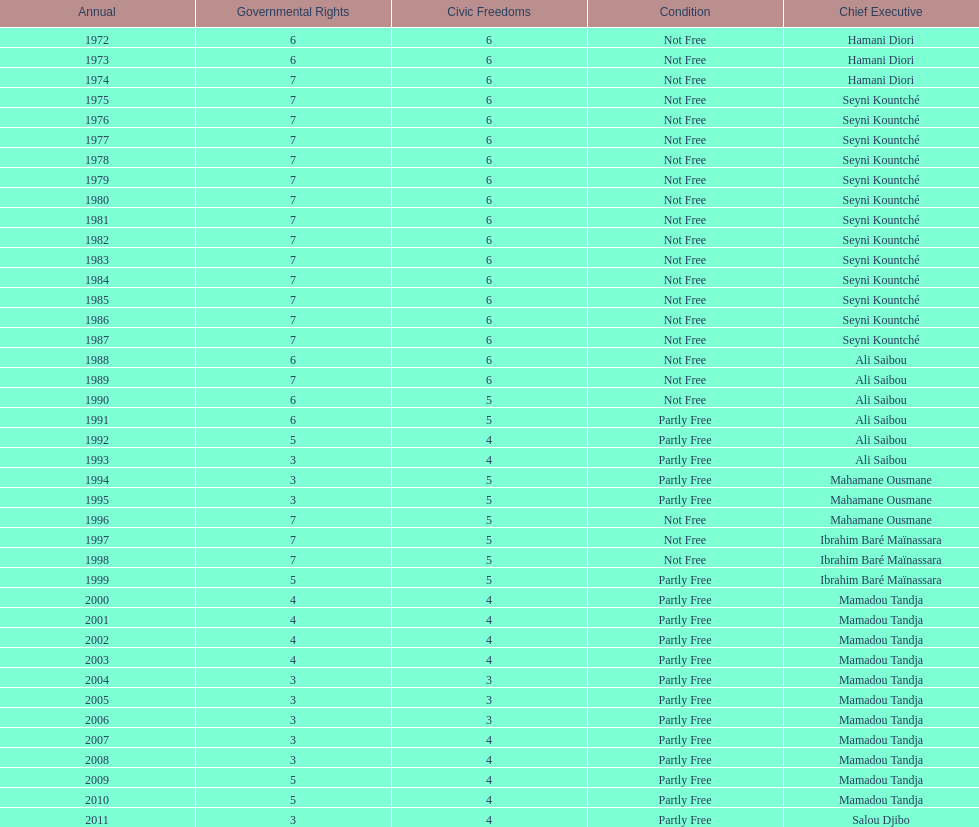Who ruled longer, ali saibou or mamadou tandja? Mamadou Tandja. 